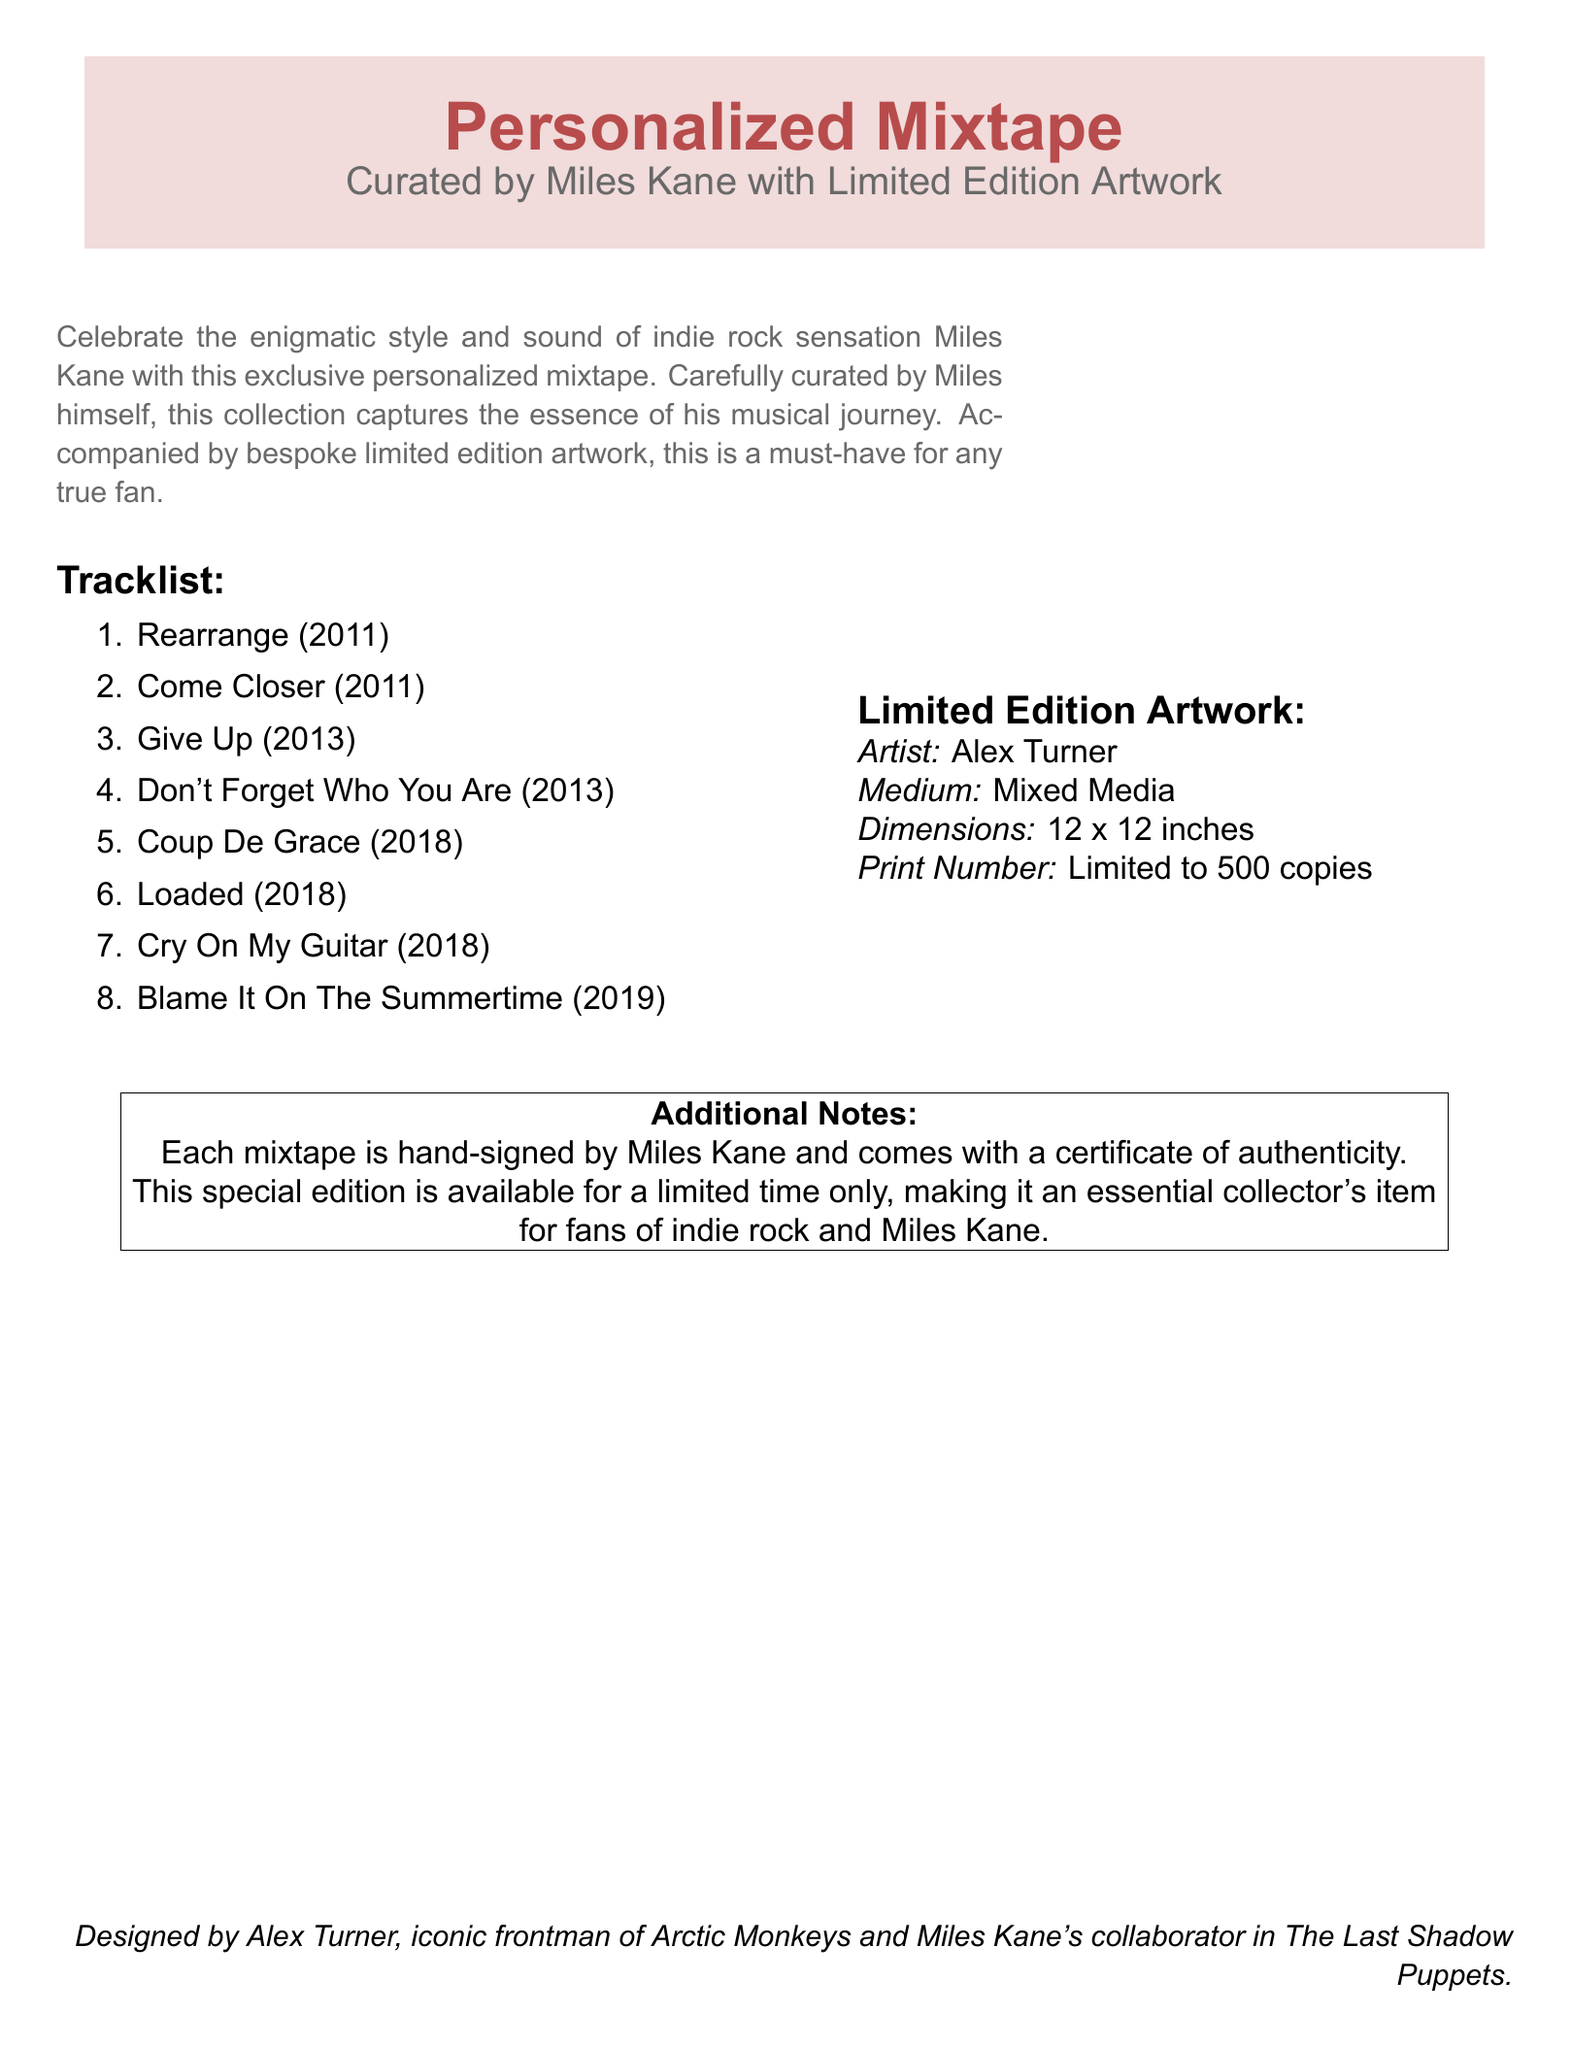What is the title of the mixtape? The title can be found at the top of the document as the main focus.
Answer: Personalized Mixtape Who curated the mixtape? This information is stated directly in the subtitle of the document.
Answer: Miles Kane How many tracks are listed on the mixtape? The number of tracks is shown in the tracklist section of the document.
Answer: 8 What is the medium of the limited edition artwork? This detail is provided in the limited edition artwork section of the document.
Answer: Mixed Media Who is the artist of the limited edition artwork? This fact is specified in the same section detailing the artwork.
Answer: Alex Turner What is the maximum number of copies of the artwork? The limited print number is stated in the document under the artwork description.
Answer: Limited to 500 copies Is the mixtape hand-signed? This is mentioned in the additional notes section.
Answer: Yes What year was "Coup De Grace" released? The year of release is indicated next to the track name in the tracklist.
Answer: 2018 